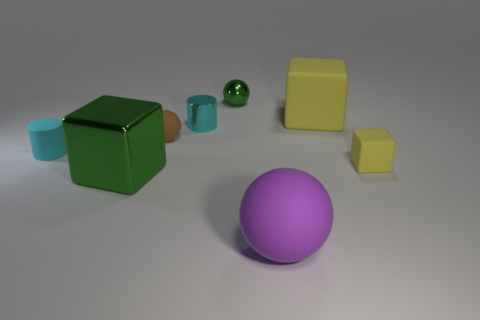Add 2 cyan metal objects. How many objects exist? 10 Subtract all cubes. How many objects are left? 5 Subtract 1 cyan cylinders. How many objects are left? 7 Subtract all blue rubber cubes. Subtract all tiny metallic things. How many objects are left? 6 Add 2 cubes. How many cubes are left? 5 Add 3 tiny balls. How many tiny balls exist? 5 